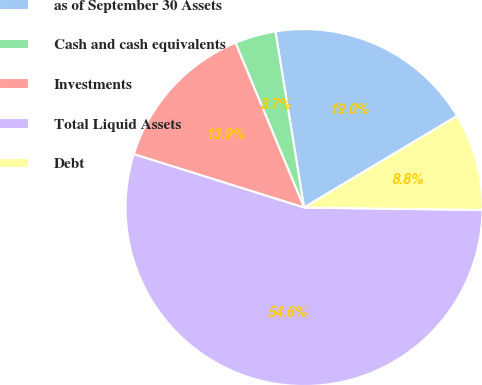Convert chart to OTSL. <chart><loc_0><loc_0><loc_500><loc_500><pie_chart><fcel>as of September 30 Assets<fcel>Cash and cash equivalents<fcel>Investments<fcel>Total Liquid Assets<fcel>Debt<nl><fcel>18.98%<fcel>3.71%<fcel>13.89%<fcel>54.61%<fcel>8.8%<nl></chart> 